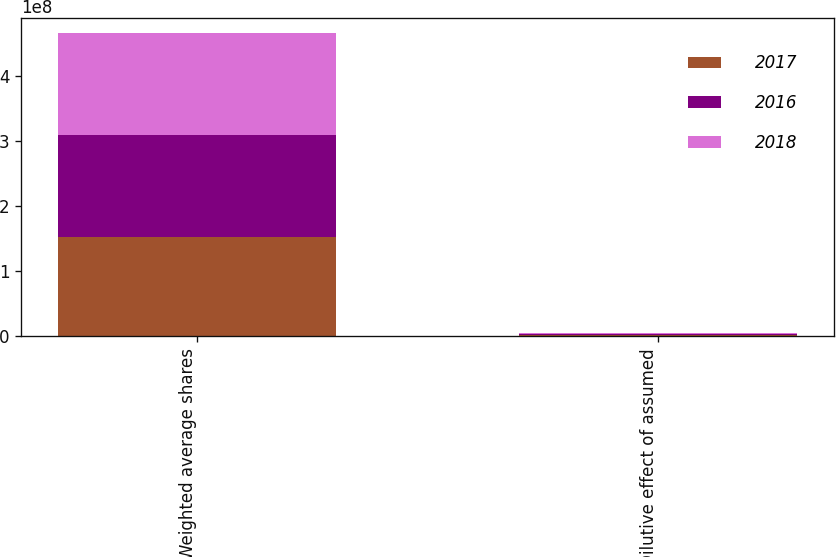Convert chart to OTSL. <chart><loc_0><loc_0><loc_500><loc_500><stacked_bar_chart><ecel><fcel>Weighted average shares<fcel>Dilutive effect of assumed<nl><fcel>2017<fcel>1.52133e+08<fcel>2.259e+06<nl><fcel>2016<fcel>1.57744e+08<fcel>2.059e+06<nl><fcel>2018<fcel>1.56636e+08<fcel>1.405e+06<nl></chart> 